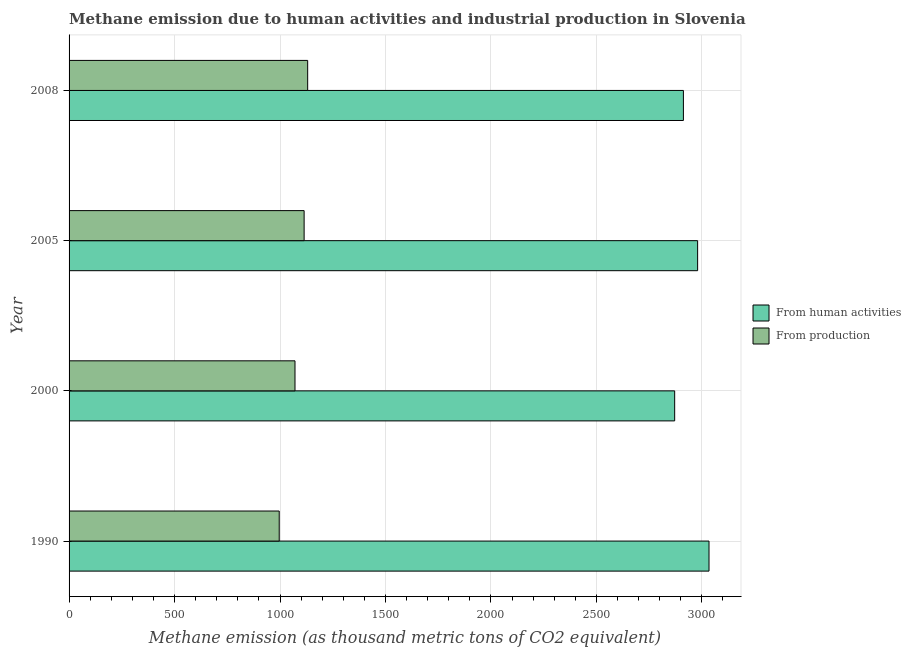How many different coloured bars are there?
Provide a short and direct response. 2. Are the number of bars per tick equal to the number of legend labels?
Your response must be concise. Yes. What is the amount of emissions generated from industries in 2005?
Your response must be concise. 1114.4. Across all years, what is the maximum amount of emissions from human activities?
Keep it short and to the point. 3033.9. Across all years, what is the minimum amount of emissions from human activities?
Provide a succinct answer. 2871.1. In which year was the amount of emissions from human activities minimum?
Keep it short and to the point. 2000. What is the total amount of emissions generated from industries in the graph?
Offer a terse response. 4313. What is the difference between the amount of emissions generated from industries in 1990 and that in 2000?
Give a very brief answer. -74.8. What is the difference between the amount of emissions from human activities in 2005 and the amount of emissions generated from industries in 2008?
Provide a short and direct response. 1848.7. What is the average amount of emissions from human activities per year?
Provide a succinct answer. 2949.35. In the year 2000, what is the difference between the amount of emissions generated from industries and amount of emissions from human activities?
Your answer should be very brief. -1800. In how many years, is the amount of emissions from human activities greater than 2700 thousand metric tons?
Keep it short and to the point. 4. Is the amount of emissions generated from industries in 2000 less than that in 2005?
Make the answer very short. Yes. What is the difference between the highest and the second highest amount of emissions generated from industries?
Ensure brevity in your answer.  16.8. What is the difference between the highest and the lowest amount of emissions from human activities?
Give a very brief answer. 162.8. In how many years, is the amount of emissions from human activities greater than the average amount of emissions from human activities taken over all years?
Keep it short and to the point. 2. Is the sum of the amount of emissions from human activities in 2005 and 2008 greater than the maximum amount of emissions generated from industries across all years?
Keep it short and to the point. Yes. What does the 1st bar from the top in 1990 represents?
Provide a short and direct response. From production. What does the 2nd bar from the bottom in 2005 represents?
Your answer should be very brief. From production. How many bars are there?
Offer a terse response. 8. How many years are there in the graph?
Provide a short and direct response. 4. What is the difference between two consecutive major ticks on the X-axis?
Offer a very short reply. 500. What is the title of the graph?
Keep it short and to the point. Methane emission due to human activities and industrial production in Slovenia. What is the label or title of the X-axis?
Give a very brief answer. Methane emission (as thousand metric tons of CO2 equivalent). What is the Methane emission (as thousand metric tons of CO2 equivalent) in From human activities in 1990?
Provide a succinct answer. 3033.9. What is the Methane emission (as thousand metric tons of CO2 equivalent) in From production in 1990?
Give a very brief answer. 996.3. What is the Methane emission (as thousand metric tons of CO2 equivalent) in From human activities in 2000?
Provide a short and direct response. 2871.1. What is the Methane emission (as thousand metric tons of CO2 equivalent) in From production in 2000?
Make the answer very short. 1071.1. What is the Methane emission (as thousand metric tons of CO2 equivalent) in From human activities in 2005?
Provide a short and direct response. 2979.9. What is the Methane emission (as thousand metric tons of CO2 equivalent) of From production in 2005?
Make the answer very short. 1114.4. What is the Methane emission (as thousand metric tons of CO2 equivalent) in From human activities in 2008?
Your response must be concise. 2912.5. What is the Methane emission (as thousand metric tons of CO2 equivalent) of From production in 2008?
Give a very brief answer. 1131.2. Across all years, what is the maximum Methane emission (as thousand metric tons of CO2 equivalent) in From human activities?
Offer a very short reply. 3033.9. Across all years, what is the maximum Methane emission (as thousand metric tons of CO2 equivalent) of From production?
Offer a terse response. 1131.2. Across all years, what is the minimum Methane emission (as thousand metric tons of CO2 equivalent) of From human activities?
Ensure brevity in your answer.  2871.1. Across all years, what is the minimum Methane emission (as thousand metric tons of CO2 equivalent) in From production?
Your answer should be very brief. 996.3. What is the total Methane emission (as thousand metric tons of CO2 equivalent) in From human activities in the graph?
Your response must be concise. 1.18e+04. What is the total Methane emission (as thousand metric tons of CO2 equivalent) of From production in the graph?
Provide a succinct answer. 4313. What is the difference between the Methane emission (as thousand metric tons of CO2 equivalent) of From human activities in 1990 and that in 2000?
Keep it short and to the point. 162.8. What is the difference between the Methane emission (as thousand metric tons of CO2 equivalent) of From production in 1990 and that in 2000?
Offer a terse response. -74.8. What is the difference between the Methane emission (as thousand metric tons of CO2 equivalent) of From human activities in 1990 and that in 2005?
Offer a terse response. 54. What is the difference between the Methane emission (as thousand metric tons of CO2 equivalent) of From production in 1990 and that in 2005?
Your answer should be compact. -118.1. What is the difference between the Methane emission (as thousand metric tons of CO2 equivalent) of From human activities in 1990 and that in 2008?
Your answer should be compact. 121.4. What is the difference between the Methane emission (as thousand metric tons of CO2 equivalent) of From production in 1990 and that in 2008?
Offer a terse response. -134.9. What is the difference between the Methane emission (as thousand metric tons of CO2 equivalent) of From human activities in 2000 and that in 2005?
Keep it short and to the point. -108.8. What is the difference between the Methane emission (as thousand metric tons of CO2 equivalent) in From production in 2000 and that in 2005?
Offer a very short reply. -43.3. What is the difference between the Methane emission (as thousand metric tons of CO2 equivalent) of From human activities in 2000 and that in 2008?
Keep it short and to the point. -41.4. What is the difference between the Methane emission (as thousand metric tons of CO2 equivalent) in From production in 2000 and that in 2008?
Give a very brief answer. -60.1. What is the difference between the Methane emission (as thousand metric tons of CO2 equivalent) in From human activities in 2005 and that in 2008?
Offer a terse response. 67.4. What is the difference between the Methane emission (as thousand metric tons of CO2 equivalent) of From production in 2005 and that in 2008?
Provide a short and direct response. -16.8. What is the difference between the Methane emission (as thousand metric tons of CO2 equivalent) of From human activities in 1990 and the Methane emission (as thousand metric tons of CO2 equivalent) of From production in 2000?
Offer a terse response. 1962.8. What is the difference between the Methane emission (as thousand metric tons of CO2 equivalent) of From human activities in 1990 and the Methane emission (as thousand metric tons of CO2 equivalent) of From production in 2005?
Make the answer very short. 1919.5. What is the difference between the Methane emission (as thousand metric tons of CO2 equivalent) in From human activities in 1990 and the Methane emission (as thousand metric tons of CO2 equivalent) in From production in 2008?
Your answer should be compact. 1902.7. What is the difference between the Methane emission (as thousand metric tons of CO2 equivalent) in From human activities in 2000 and the Methane emission (as thousand metric tons of CO2 equivalent) in From production in 2005?
Offer a terse response. 1756.7. What is the difference between the Methane emission (as thousand metric tons of CO2 equivalent) of From human activities in 2000 and the Methane emission (as thousand metric tons of CO2 equivalent) of From production in 2008?
Offer a terse response. 1739.9. What is the difference between the Methane emission (as thousand metric tons of CO2 equivalent) of From human activities in 2005 and the Methane emission (as thousand metric tons of CO2 equivalent) of From production in 2008?
Offer a very short reply. 1848.7. What is the average Methane emission (as thousand metric tons of CO2 equivalent) in From human activities per year?
Offer a terse response. 2949.35. What is the average Methane emission (as thousand metric tons of CO2 equivalent) in From production per year?
Make the answer very short. 1078.25. In the year 1990, what is the difference between the Methane emission (as thousand metric tons of CO2 equivalent) in From human activities and Methane emission (as thousand metric tons of CO2 equivalent) in From production?
Offer a very short reply. 2037.6. In the year 2000, what is the difference between the Methane emission (as thousand metric tons of CO2 equivalent) in From human activities and Methane emission (as thousand metric tons of CO2 equivalent) in From production?
Provide a short and direct response. 1800. In the year 2005, what is the difference between the Methane emission (as thousand metric tons of CO2 equivalent) in From human activities and Methane emission (as thousand metric tons of CO2 equivalent) in From production?
Your response must be concise. 1865.5. In the year 2008, what is the difference between the Methane emission (as thousand metric tons of CO2 equivalent) in From human activities and Methane emission (as thousand metric tons of CO2 equivalent) in From production?
Offer a very short reply. 1781.3. What is the ratio of the Methane emission (as thousand metric tons of CO2 equivalent) of From human activities in 1990 to that in 2000?
Your answer should be very brief. 1.06. What is the ratio of the Methane emission (as thousand metric tons of CO2 equivalent) of From production in 1990 to that in 2000?
Give a very brief answer. 0.93. What is the ratio of the Methane emission (as thousand metric tons of CO2 equivalent) of From human activities in 1990 to that in 2005?
Give a very brief answer. 1.02. What is the ratio of the Methane emission (as thousand metric tons of CO2 equivalent) of From production in 1990 to that in 2005?
Provide a short and direct response. 0.89. What is the ratio of the Methane emission (as thousand metric tons of CO2 equivalent) of From human activities in 1990 to that in 2008?
Your response must be concise. 1.04. What is the ratio of the Methane emission (as thousand metric tons of CO2 equivalent) in From production in 1990 to that in 2008?
Offer a terse response. 0.88. What is the ratio of the Methane emission (as thousand metric tons of CO2 equivalent) in From human activities in 2000 to that in 2005?
Your answer should be compact. 0.96. What is the ratio of the Methane emission (as thousand metric tons of CO2 equivalent) in From production in 2000 to that in 2005?
Offer a very short reply. 0.96. What is the ratio of the Methane emission (as thousand metric tons of CO2 equivalent) of From human activities in 2000 to that in 2008?
Ensure brevity in your answer.  0.99. What is the ratio of the Methane emission (as thousand metric tons of CO2 equivalent) of From production in 2000 to that in 2008?
Provide a succinct answer. 0.95. What is the ratio of the Methane emission (as thousand metric tons of CO2 equivalent) of From human activities in 2005 to that in 2008?
Keep it short and to the point. 1.02. What is the ratio of the Methane emission (as thousand metric tons of CO2 equivalent) of From production in 2005 to that in 2008?
Your response must be concise. 0.99. What is the difference between the highest and the second highest Methane emission (as thousand metric tons of CO2 equivalent) of From production?
Ensure brevity in your answer.  16.8. What is the difference between the highest and the lowest Methane emission (as thousand metric tons of CO2 equivalent) in From human activities?
Provide a short and direct response. 162.8. What is the difference between the highest and the lowest Methane emission (as thousand metric tons of CO2 equivalent) of From production?
Offer a very short reply. 134.9. 